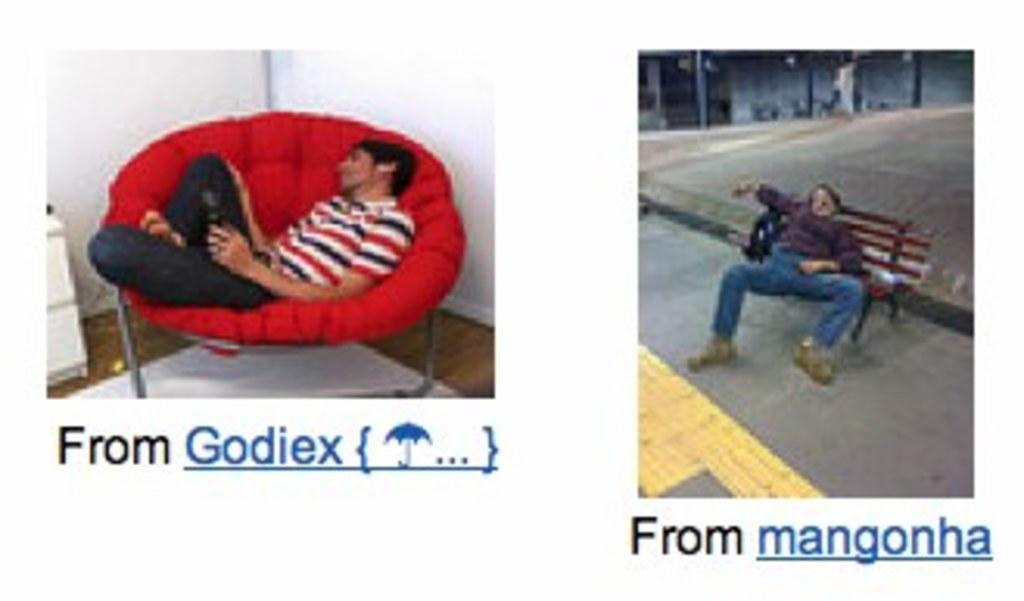What is the color of the sofa on which a person is sleeping? The sofa is red, and a person is sleeping on it. Where is the second person sleeping? The second person is sleeping on a bench. What can be found under the red sofa? There is something written under the red sofa. What can be found under the bench? There is something written under the bench. What type of leather is used to make the rake in the image? There is no rake present in the image, so it is not possible to determine the type of leather used to make it. 